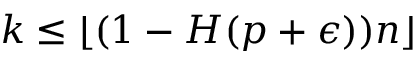<formula> <loc_0><loc_0><loc_500><loc_500>k \leq \lfloor ( 1 - H ( p + \epsilon ) ) n \rfloor</formula> 